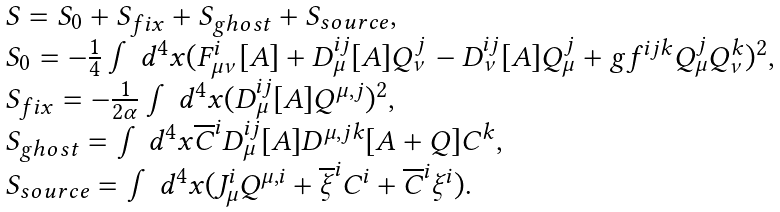<formula> <loc_0><loc_0><loc_500><loc_500>\begin{array} { l } S = S _ { 0 } + S _ { f i x } + S _ { g h o s t } + S _ { s o u r c e } , \\ S _ { 0 } = - \frac { 1 } { 4 } \int d ^ { 4 } x ( F _ { \mu \nu } ^ { i } [ A ] + D _ { \mu } ^ { i j } [ A ] Q _ { \nu } ^ { j } - D _ { \nu } ^ { i j } [ A ] Q _ { \mu } ^ { j } + g f ^ { i j k } Q _ { \mu } ^ { j } Q _ { \nu } ^ { k } ) ^ { 2 } , \\ S _ { f i x } = - \frac { 1 } { 2 \alpha } \int d ^ { 4 } x ( D _ { \mu } ^ { i j } [ A ] Q ^ { \mu , j } ) ^ { 2 } , \\ S _ { g h o s t } = \int d ^ { 4 } x \overline { C } ^ { i } D _ { \mu } ^ { i j } [ A ] D ^ { \mu , j k } [ A + Q ] C ^ { k } , \\ S _ { s o u r c e } = \int d ^ { 4 } x ( J _ { \mu } ^ { i } Q ^ { \mu , i } + \overline { \xi } ^ { i } C ^ { i } + \overline { C } ^ { i } \xi ^ { i } ) . \end{array}</formula> 